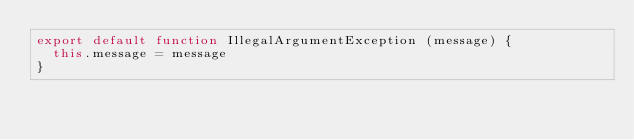Convert code to text. <code><loc_0><loc_0><loc_500><loc_500><_JavaScript_>export default function IllegalArgumentException (message) {
  this.message = message
}
</code> 